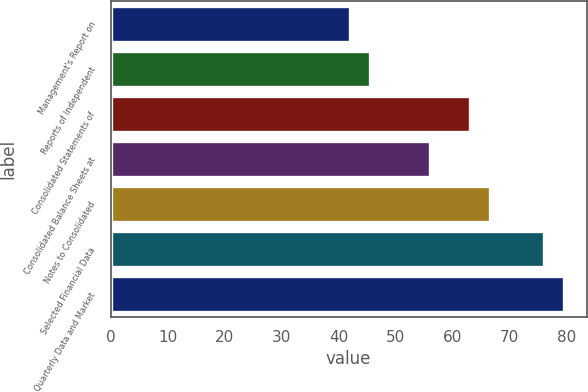Convert chart. <chart><loc_0><loc_0><loc_500><loc_500><bar_chart><fcel>Management's Report on<fcel>Reports of Independent<fcel>Consolidated Statements of<fcel>Consolidated Balance Sheets at<fcel>Notes to Consolidated<fcel>Selected Financial Data<fcel>Quarterly Data and Market<nl><fcel>42<fcel>45.5<fcel>63<fcel>56<fcel>66.5<fcel>76<fcel>79.5<nl></chart> 